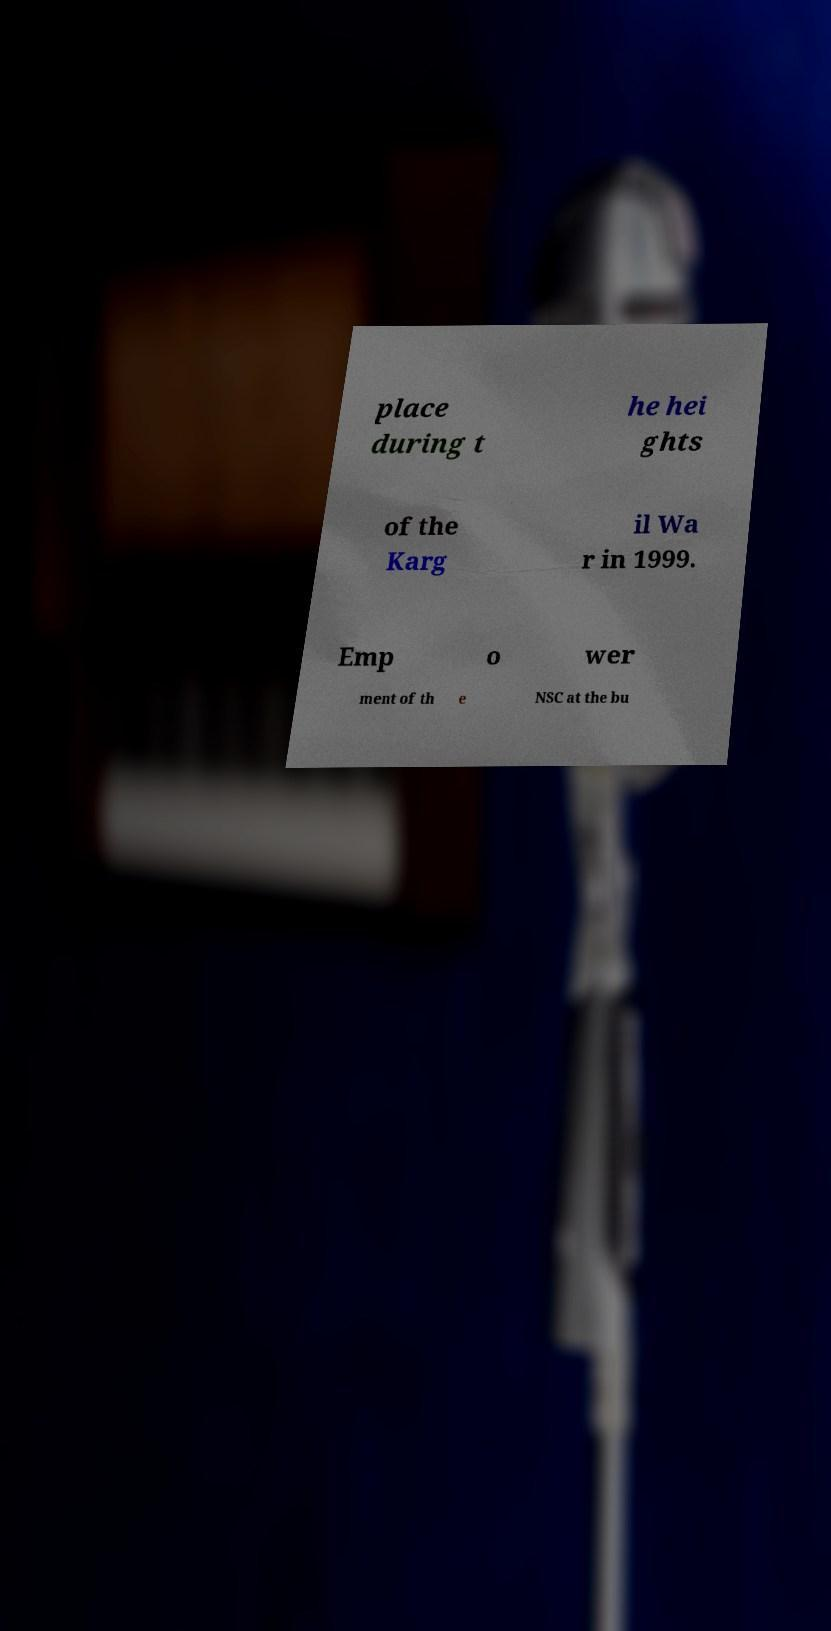Please identify and transcribe the text found in this image. place during t he hei ghts of the Karg il Wa r in 1999. Emp o wer ment of th e NSC at the bu 